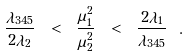<formula> <loc_0><loc_0><loc_500><loc_500>\frac { \lambda _ { 3 4 5 } } { 2 \lambda _ { 2 } } \ < \ \frac { \mu _ { 1 } ^ { 2 } } { \mu _ { 2 } ^ { 2 } } \ < \ \frac { 2 \lambda _ { 1 } } { \lambda _ { 3 4 5 } } \ .</formula> 